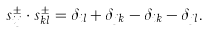Convert formula to latex. <formula><loc_0><loc_0><loc_500><loc_500>s _ { i j } ^ { \pm } \cdot s _ { k l } ^ { \pm } = \delta _ { i l } + \delta _ { j k } - \delta _ { i k } - \delta _ { j l } .</formula> 